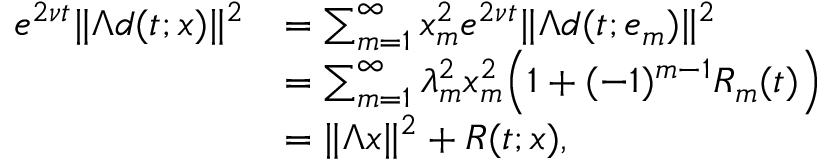Convert formula to latex. <formula><loc_0><loc_0><loc_500><loc_500>\begin{array} { r l } { e ^ { 2 \nu t } \| \Lambda d ( t ; x ) \| ^ { 2 } } & { = \sum _ { m = 1 } ^ { \infty } x _ { m } ^ { 2 } e ^ { 2 \nu t } \| \Lambda d ( t ; e _ { m } ) \| ^ { 2 } } \\ & { = \sum _ { m = 1 } ^ { \infty } \lambda _ { m } ^ { 2 } x _ { m } ^ { 2 } \left ( 1 + ( - 1 ) ^ { m - 1 } R _ { m } ( t ) \right ) } \\ & { = \| \Lambda x \| ^ { 2 } + R ( t ; x ) , } \end{array}</formula> 